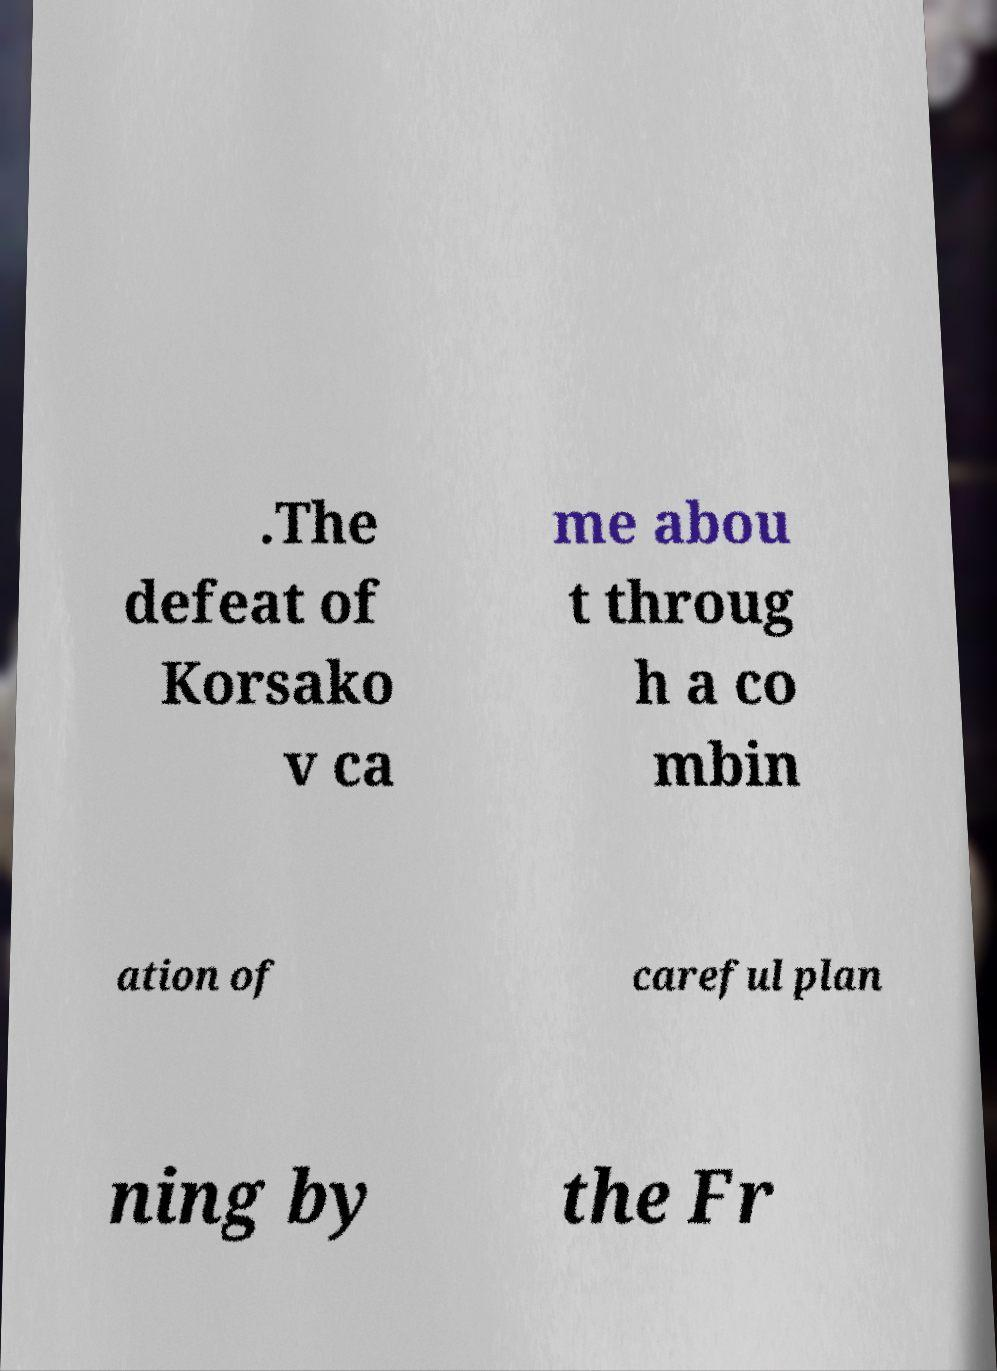Can you accurately transcribe the text from the provided image for me? .The defeat of Korsako v ca me abou t throug h a co mbin ation of careful plan ning by the Fr 